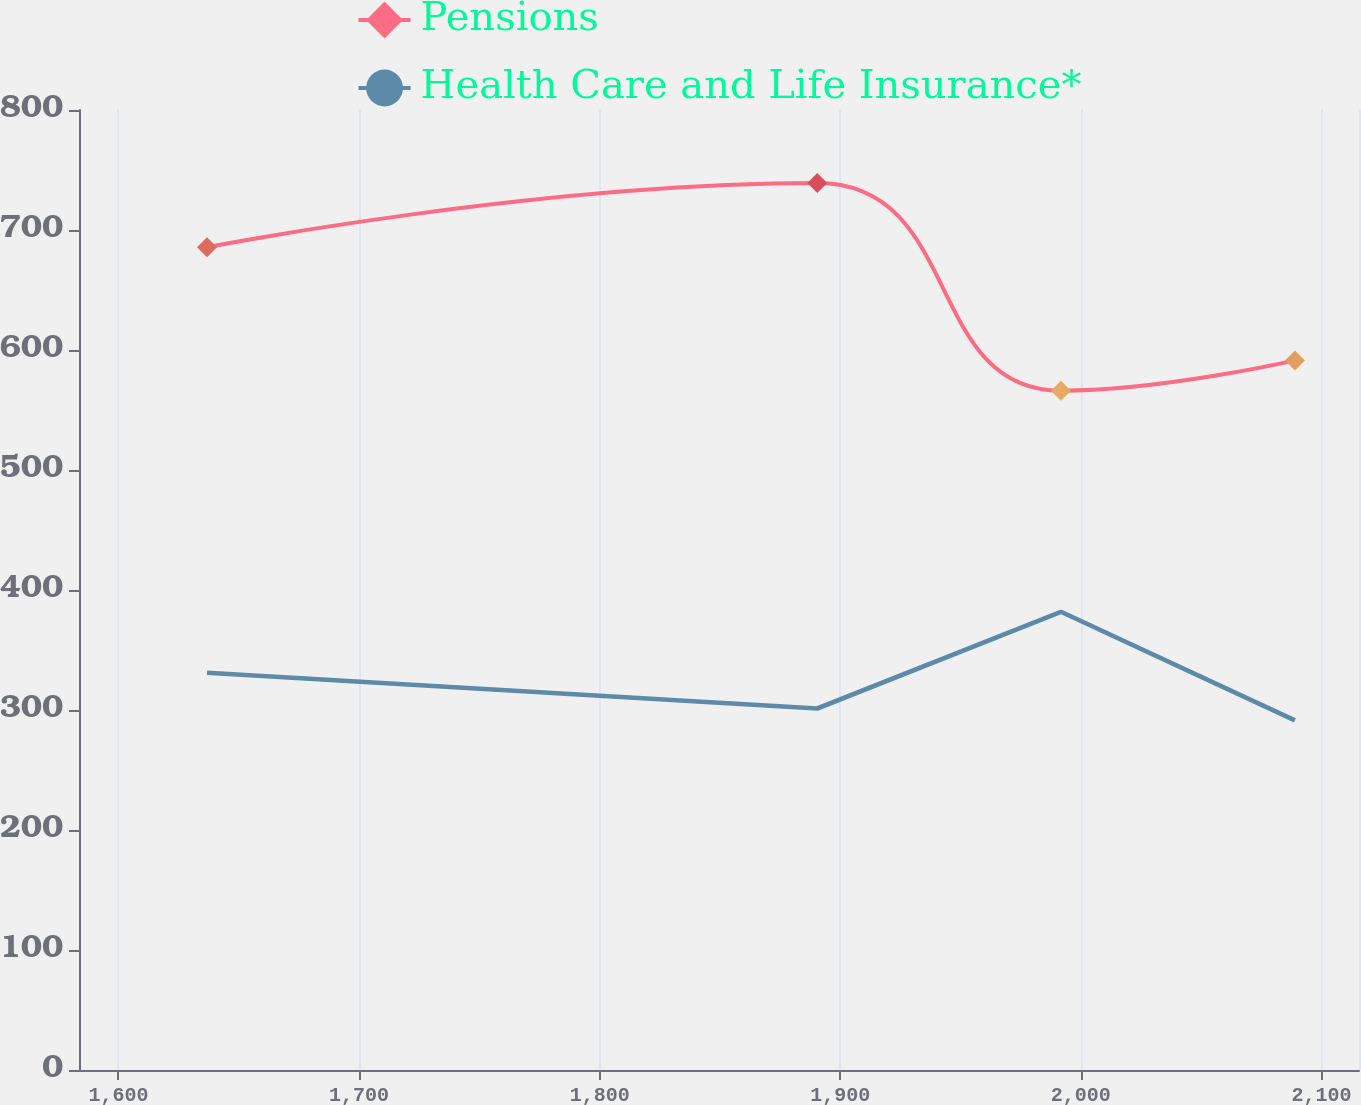Convert chart. <chart><loc_0><loc_0><loc_500><loc_500><line_chart><ecel><fcel>Pensions<fcel>Health Care and Life Insurance*<nl><fcel>1636.79<fcel>685.69<fcel>330.98<nl><fcel>1890.45<fcel>739.09<fcel>301.24<nl><fcel>1991.74<fcel>566.14<fcel>381.86<nl><fcel>2089<fcel>591.34<fcel>291.39<nl><fcel>2168.84<fcel>723.22<fcel>391.71<nl></chart> 